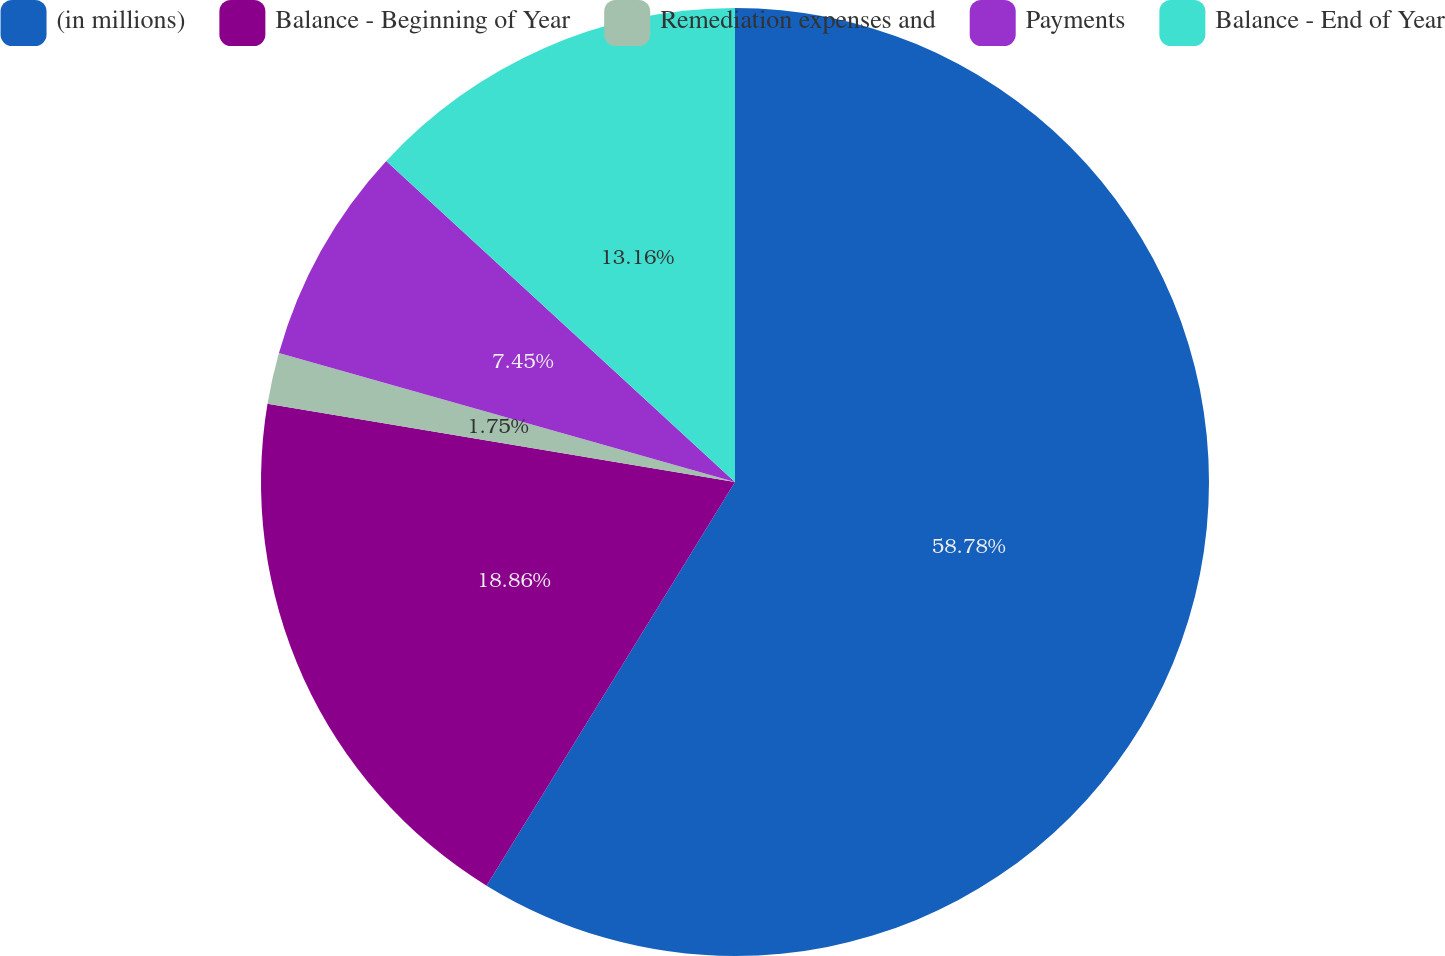Convert chart. <chart><loc_0><loc_0><loc_500><loc_500><pie_chart><fcel>(in millions)<fcel>Balance - Beginning of Year<fcel>Remediation expenses and<fcel>Payments<fcel>Balance - End of Year<nl><fcel>58.78%<fcel>18.86%<fcel>1.75%<fcel>7.45%<fcel>13.16%<nl></chart> 